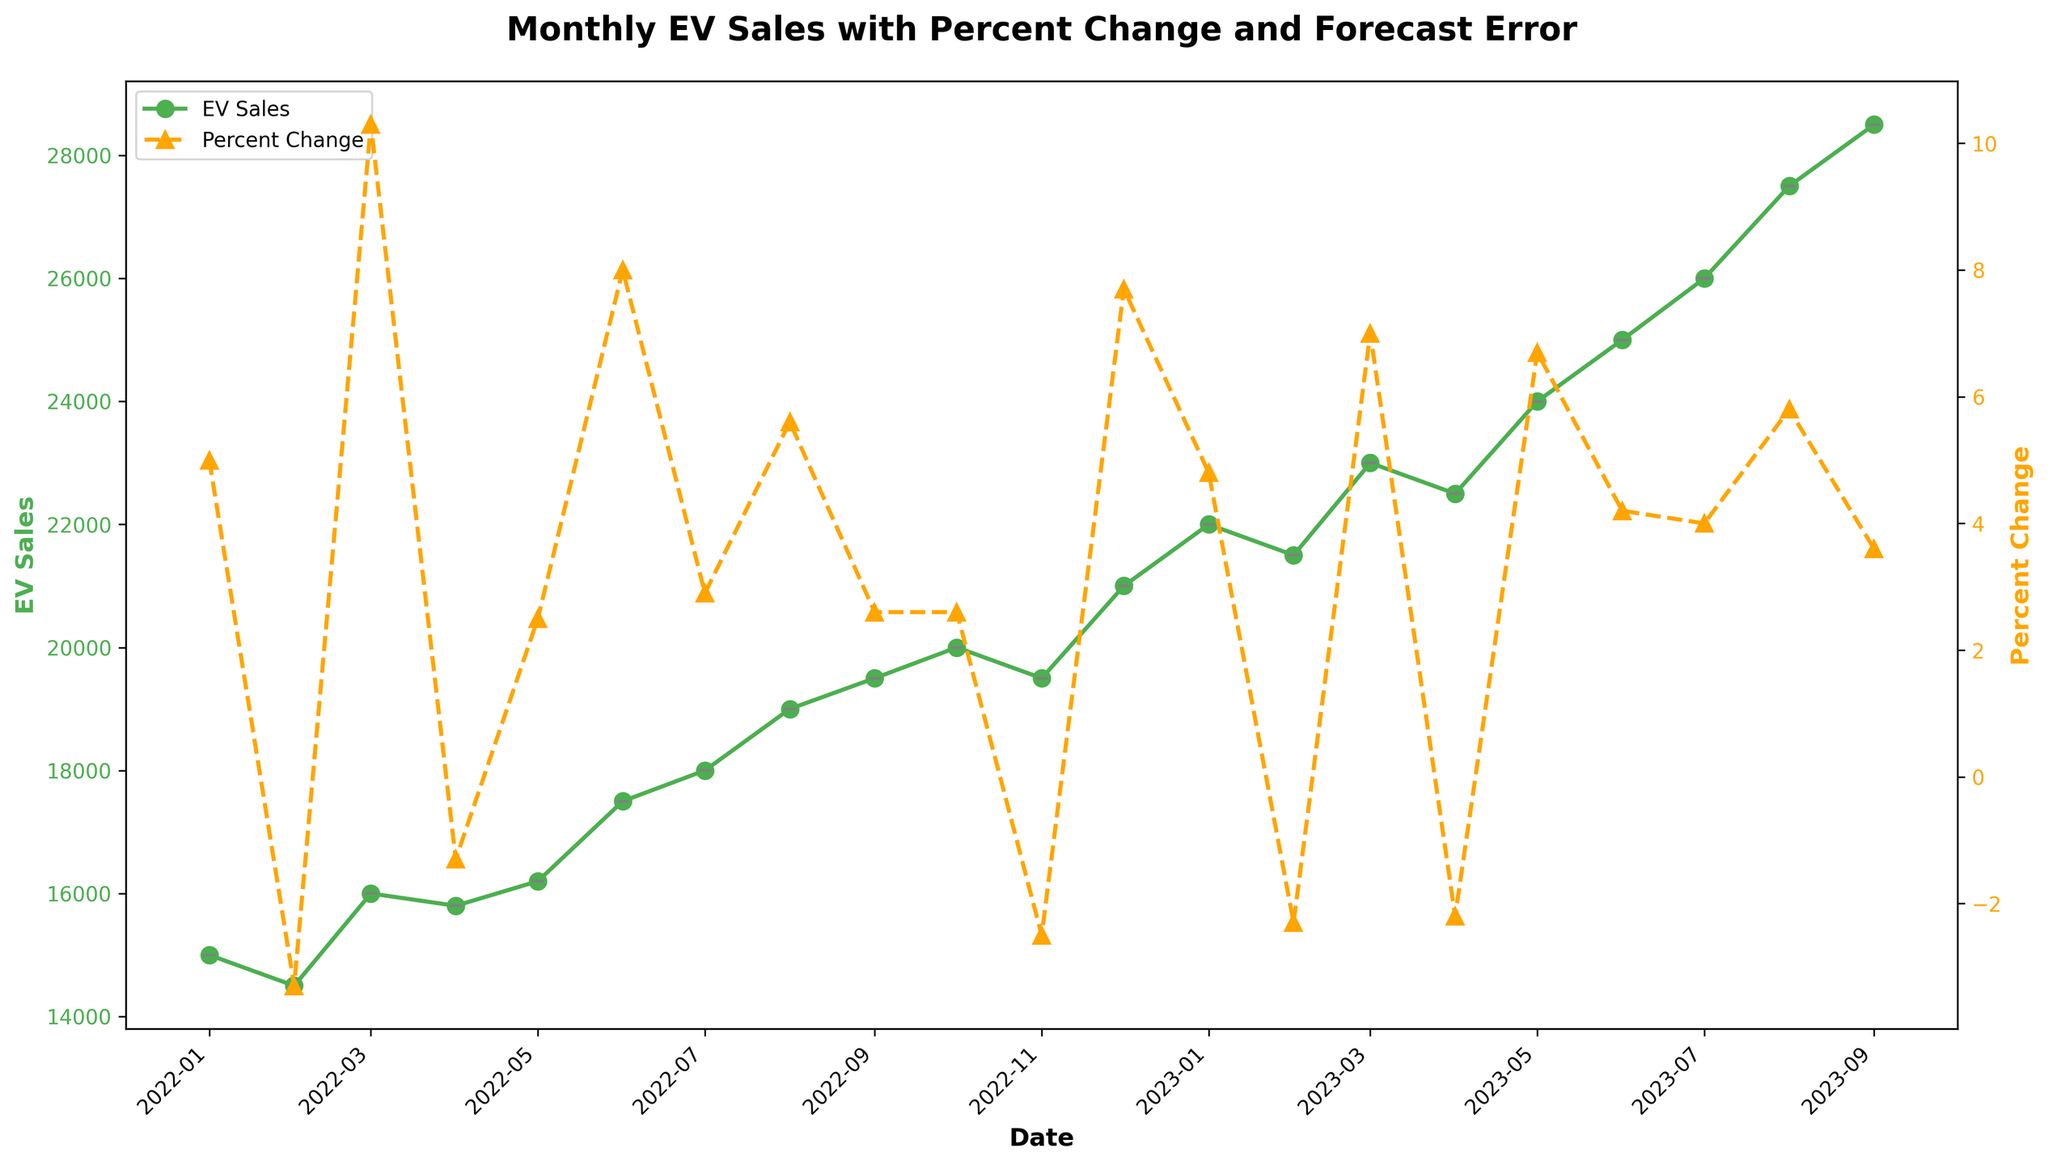What's the title of the figure? The title is usually located at the top of the figure and is meant to summarize the overall topic of the plot. In this case, it reads "Monthly EV Sales with Percent Change and Forecast Error".
Answer: Monthly EV Sales with Percent Change and Forecast Error What are the colors used to represent EV Sales and Percent Change lines? By looking at the lines marked on the figure, one can identify the colors. The line for EV Sales is green, and the line for Percent Change is orange.
Answer: Green for EV Sales, Orange for Percent Change In which month and year was the highest EV sales recorded? To find the highest sales, look for the peak value on the EV Sales line (green line). The peak occurs at 28,500 in September 2023.
Answer: September 2023 How many data points are represented in the plot? Counting the markers on the x-axis from January 2022 to September 2023, we see 21 data points represented.
Answer: 21 What is the range of forecast errors in the plot? By examining the error bars along the EV Sales line, the lowest error is 2.8 and the highest error is 4.9.
Answer: 2.8 to 4.9 Which month had the highest percentage change and what was the value? To identify the highest percentage change, look at the peak value on the Percent Change line (orange line). The peak value is in March 2022 with a 10.3% change.
Answer: March 2022, 10.3% How does the EV Sales trend compare from January 2022 to December 2022? Comparing the start and end points of the green line within the year 2022, sales start at 15,000 in January and rise to 21,000 in December. Despite fluctuations, there is an overall increasing trend.
Answer: Increasing trend What was the forecast error for July 2023? By finding July 2023 on the x-axis and checking the corresponding error bar values, we see an error of 4.5.
Answer: 4.5 In which month and year did the EV sales decrease for the second consecutive time and what was the sales number? By finding the periods with consecutive decreases in the green line and checking their values, February 2022 and April 2023 each saw decreases, with April 2023 having 22,500 sales.
Answer: April 2023, 22,500 Calculate the average EV Sales for the first six months of 2023. The data points for the first six months are 22,000, 21,500, 23,000, 22,500, 24,000, and 25,000. Summing these values gives (22,000 + 21,500 + 23,000 + 22,500 + 24,000 + 25,000) = 138,000. Dividing by 6 yields 23,000.
Answer: 23,000 